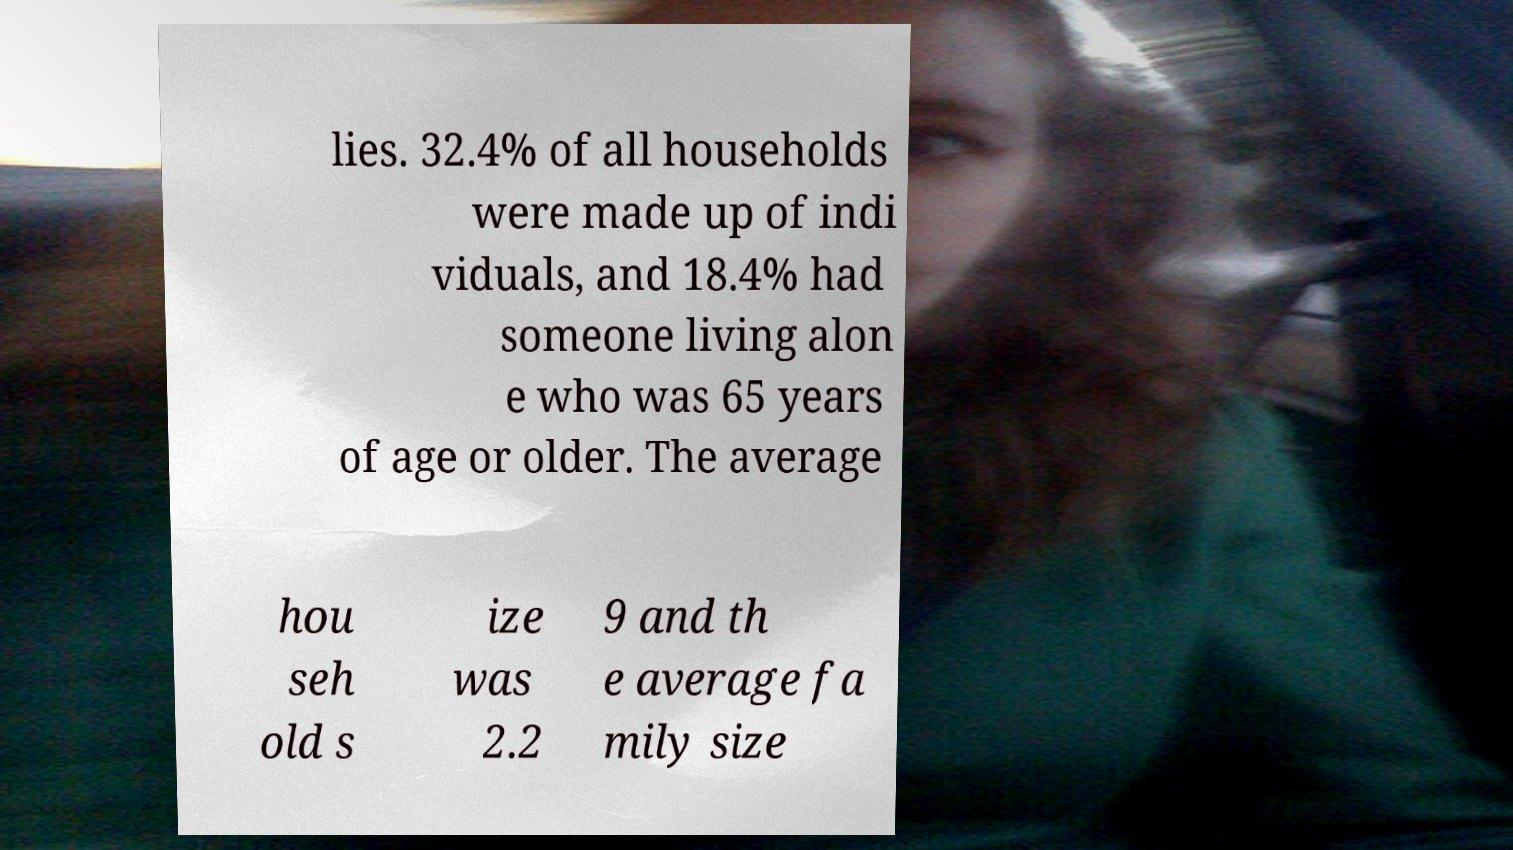What messages or text are displayed in this image? I need them in a readable, typed format. lies. 32.4% of all households were made up of indi viduals, and 18.4% had someone living alon e who was 65 years of age or older. The average hou seh old s ize was 2.2 9 and th e average fa mily size 